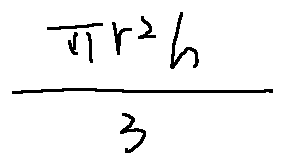<formula> <loc_0><loc_0><loc_500><loc_500>\frac { \pi r ^ { 2 } h } { 3 }</formula> 